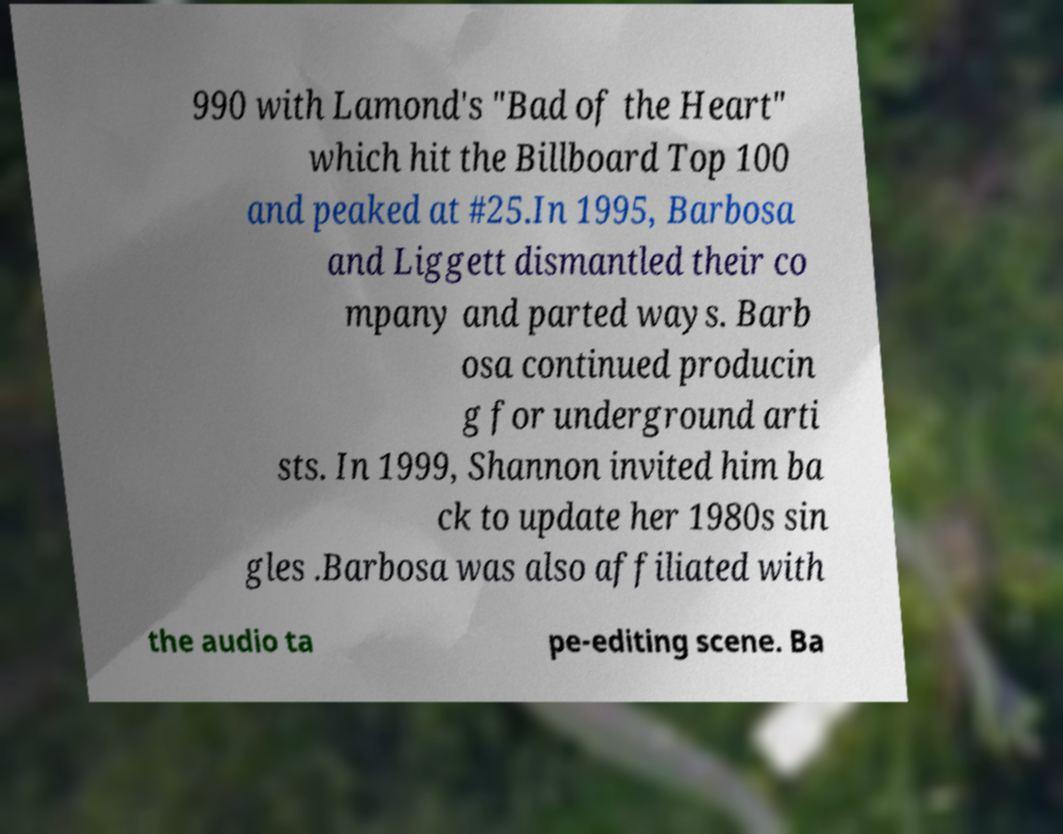I need the written content from this picture converted into text. Can you do that? 990 with Lamond's "Bad of the Heart" which hit the Billboard Top 100 and peaked at #25.In 1995, Barbosa and Liggett dismantled their co mpany and parted ways. Barb osa continued producin g for underground arti sts. In 1999, Shannon invited him ba ck to update her 1980s sin gles .Barbosa was also affiliated with the audio ta pe-editing scene. Ba 